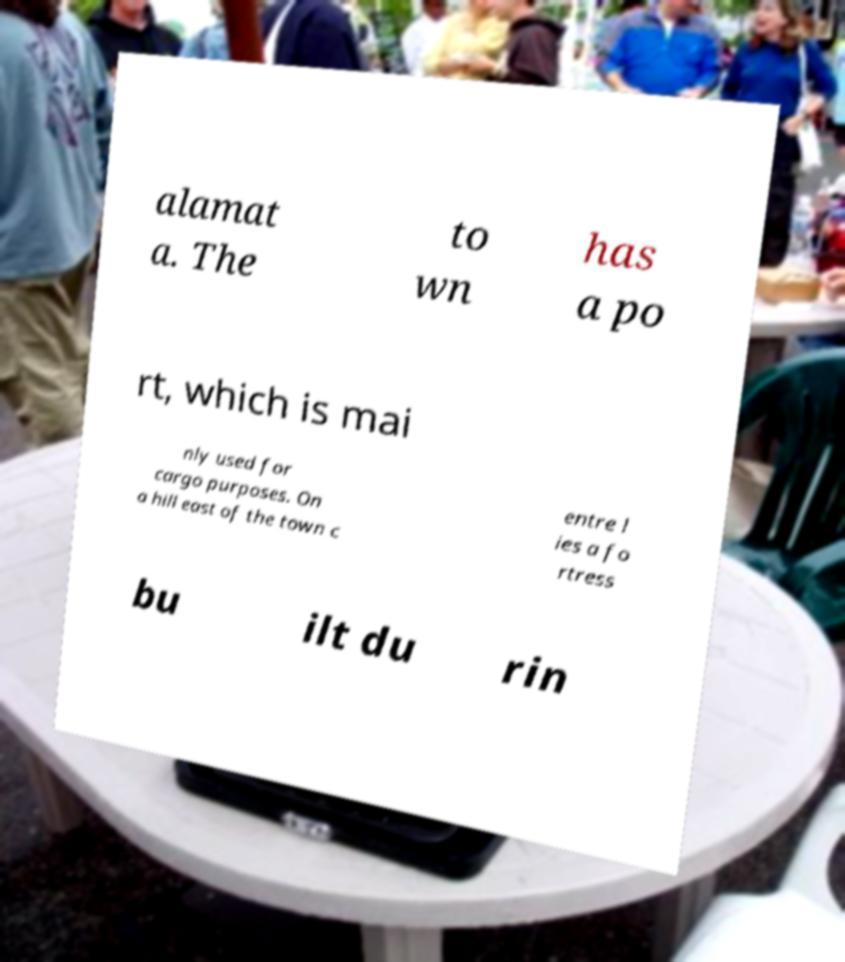Please read and relay the text visible in this image. What does it say? alamat a. The to wn has a po rt, which is mai nly used for cargo purposes. On a hill east of the town c entre l ies a fo rtress bu ilt du rin 